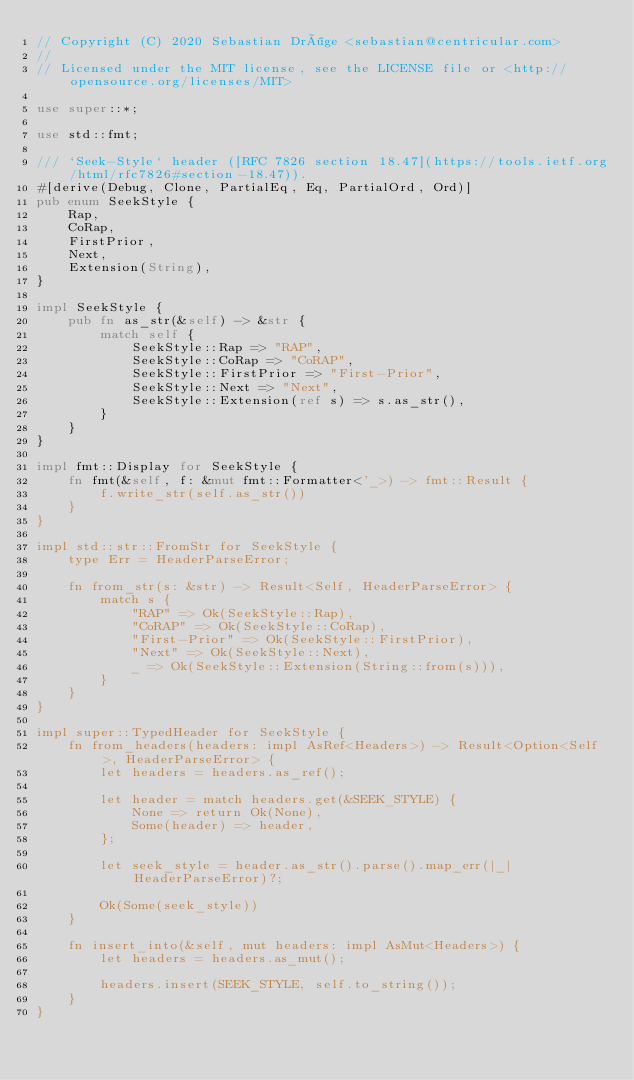Convert code to text. <code><loc_0><loc_0><loc_500><loc_500><_Rust_>// Copyright (C) 2020 Sebastian Dröge <sebastian@centricular.com>
//
// Licensed under the MIT license, see the LICENSE file or <http://opensource.org/licenses/MIT>

use super::*;

use std::fmt;

/// `Seek-Style` header ([RFC 7826 section 18.47](https://tools.ietf.org/html/rfc7826#section-18.47)).
#[derive(Debug, Clone, PartialEq, Eq, PartialOrd, Ord)]
pub enum SeekStyle {
    Rap,
    CoRap,
    FirstPrior,
    Next,
    Extension(String),
}

impl SeekStyle {
    pub fn as_str(&self) -> &str {
        match self {
            SeekStyle::Rap => "RAP",
            SeekStyle::CoRap => "CoRAP",
            SeekStyle::FirstPrior => "First-Prior",
            SeekStyle::Next => "Next",
            SeekStyle::Extension(ref s) => s.as_str(),
        }
    }
}

impl fmt::Display for SeekStyle {
    fn fmt(&self, f: &mut fmt::Formatter<'_>) -> fmt::Result {
        f.write_str(self.as_str())
    }
}

impl std::str::FromStr for SeekStyle {
    type Err = HeaderParseError;

    fn from_str(s: &str) -> Result<Self, HeaderParseError> {
        match s {
            "RAP" => Ok(SeekStyle::Rap),
            "CoRAP" => Ok(SeekStyle::CoRap),
            "First-Prior" => Ok(SeekStyle::FirstPrior),
            "Next" => Ok(SeekStyle::Next),
            _ => Ok(SeekStyle::Extension(String::from(s))),
        }
    }
}

impl super::TypedHeader for SeekStyle {
    fn from_headers(headers: impl AsRef<Headers>) -> Result<Option<Self>, HeaderParseError> {
        let headers = headers.as_ref();

        let header = match headers.get(&SEEK_STYLE) {
            None => return Ok(None),
            Some(header) => header,
        };

        let seek_style = header.as_str().parse().map_err(|_| HeaderParseError)?;

        Ok(Some(seek_style))
    }

    fn insert_into(&self, mut headers: impl AsMut<Headers>) {
        let headers = headers.as_mut();

        headers.insert(SEEK_STYLE, self.to_string());
    }
}
</code> 